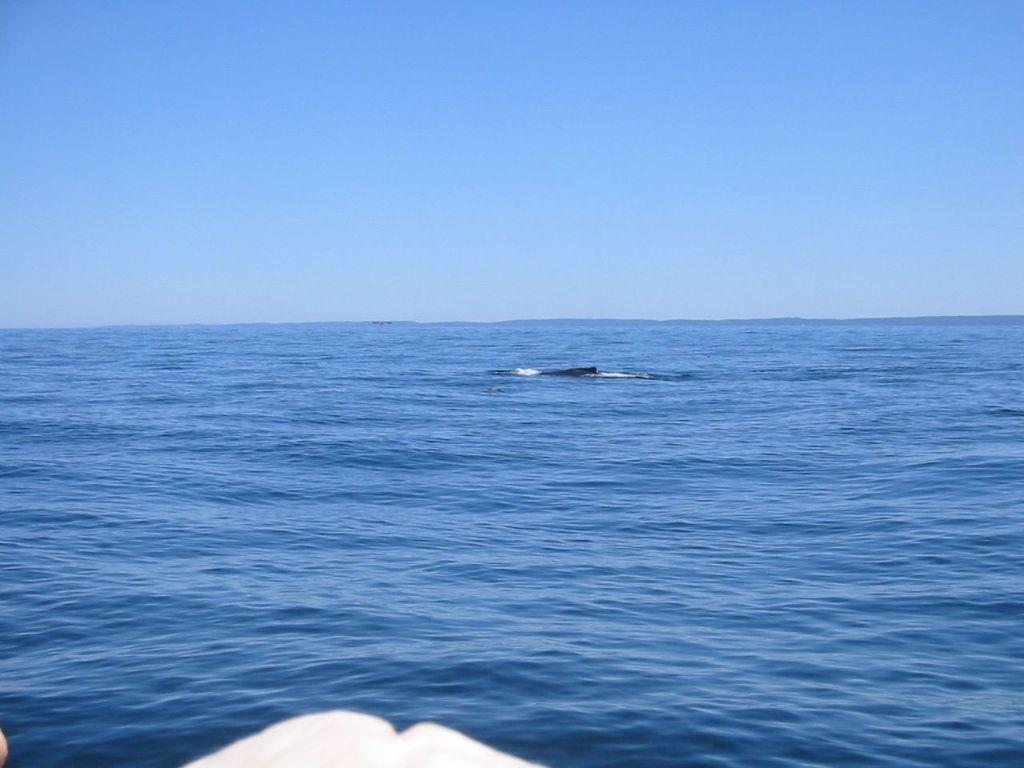What is floating on the water in the image? There is an object floating on the water in the image. What is the color of the object at the bottom of the image? The object at the bottom of the image is white. What can be seen in the background of the image? The sky is visible in the background of the image. Can you see a dog playing with jelly in the image? There is no dog or jelly present in the image. How many steps are visible in the image? There are no steps visible in the image. 